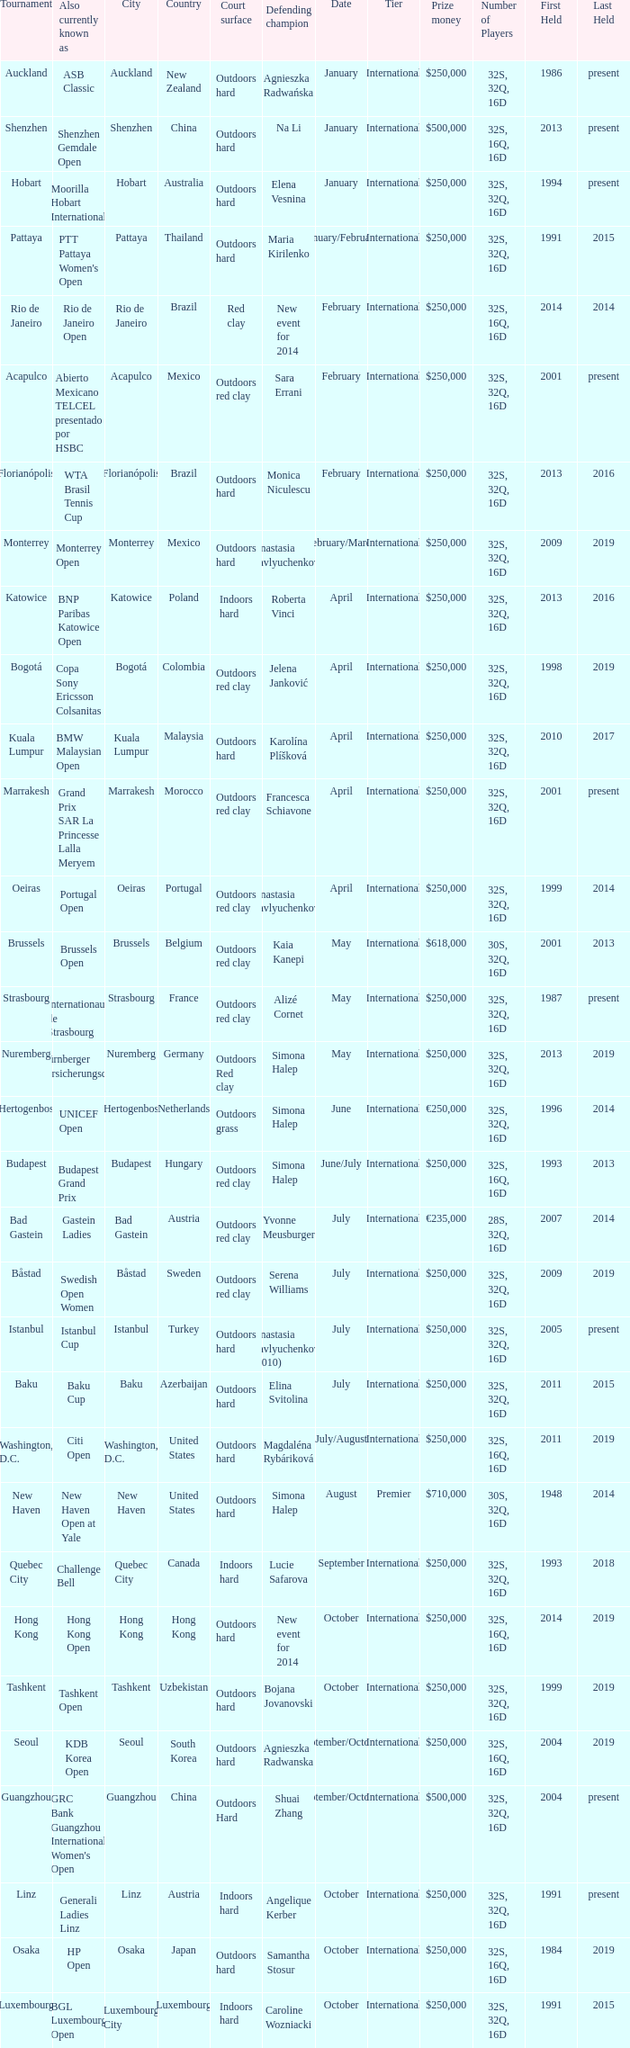How many defending champs from thailand? 1.0. 